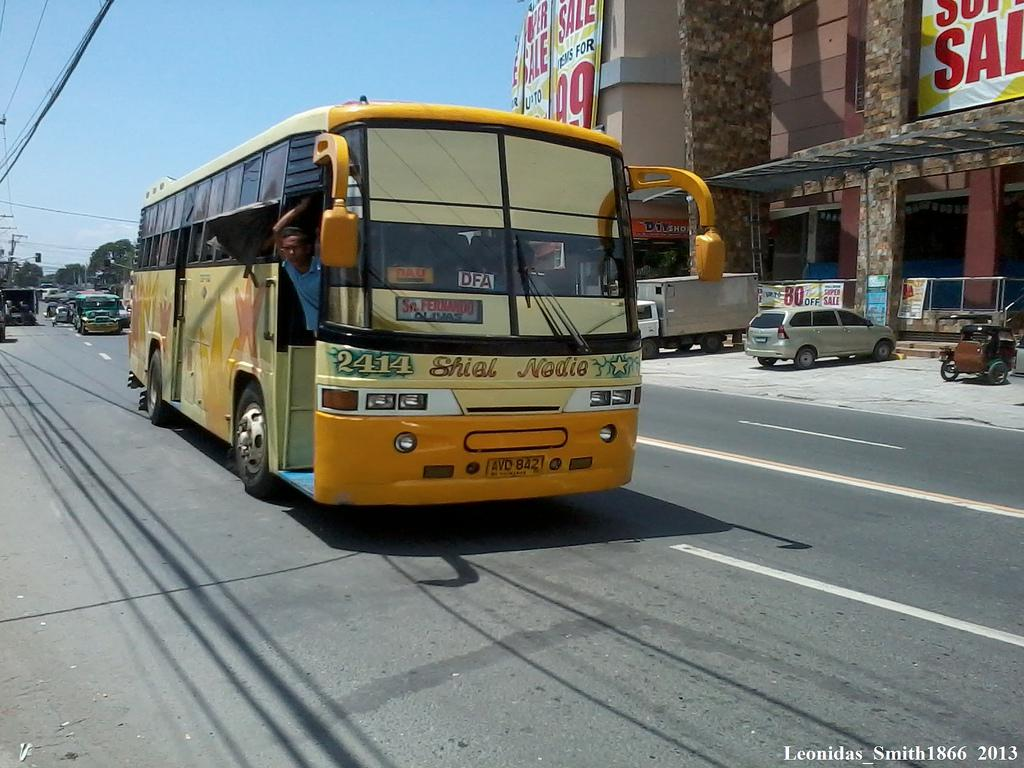Question: what color lines are on the street?
Choices:
A. White.
B. Yellow.
C. Red.
D. Orange.
Answer with the letter. Answer: A Question: what color is the ground?
Choices:
A. Green.
B. Tan.
C. Black.
D. Gray.
Answer with the letter. Answer: D Question: where is this scene?
Choices:
A. In the middle of woods.
B. At a racetrack.
C. Outdoors.
D. At a wedding.
Answer with the letter. Answer: C Question: what color is the bus?
Choices:
A. Red.
B. Blue.
C. Yellow.
D. Green.
Answer with the letter. Answer: C Question: when will the man exit the bus?
Choices:
A. When it stops.
B. Soon.
C. In a moment.
D. When the door opens.
Answer with the letter. Answer: A Question: why are there banners on the building?
Choices:
A. A sale.
B. To advertise.
C. To celebrate an anniversary.
D. To mark a holiday.
Answer with the letter. Answer: A Question: where was the photo taken?
Choices:
A. Downtown.
B. On the street.
C. In the city.
D. Outside.
Answer with the letter. Answer: B Question: what is the bus going past?
Choices:
A. The photographer.
B. An intersection.
C. A park.
D. A store.
Answer with the letter. Answer: D Question: where are the cars?
Choices:
A. In the garage.
B. In the driveway.
C. Parked at the store.
D. In the parking garage.
Answer with the letter. Answer: C Question: what is the man doing?
Choices:
A. Hanging his head out of the bus.
B. Talking on the phone.
C. Reading the newspaper.
D. Clipping coupons.
Answer with the letter. Answer: A Question: who is leaning out of the bus?
Choices:
A. A man.
B. A woman.
C. A boy.
D. A girl.
Answer with the letter. Answer: A Question: where is the green bus?
Choices:
A. Behind the red bus.
B. In front of the blue bus.
C. To the right of the white bus.
D. Bend the yellow bus.
Answer with the letter. Answer: D Question: where are the lines that are casting shadows?
Choices:
A. Overhead.
B. To the right.
C. To the left.
D. In front.
Answer with the letter. Answer: A Question: how many lanes on this street?
Choices:
A. Two.
B. Four.
C. Three.
D. Five.
Answer with the letter. Answer: B Question: how many clouds are in the sky?
Choices:
A. One.
B. None.
C. Two.
D. Three.
Answer with the letter. Answer: B 